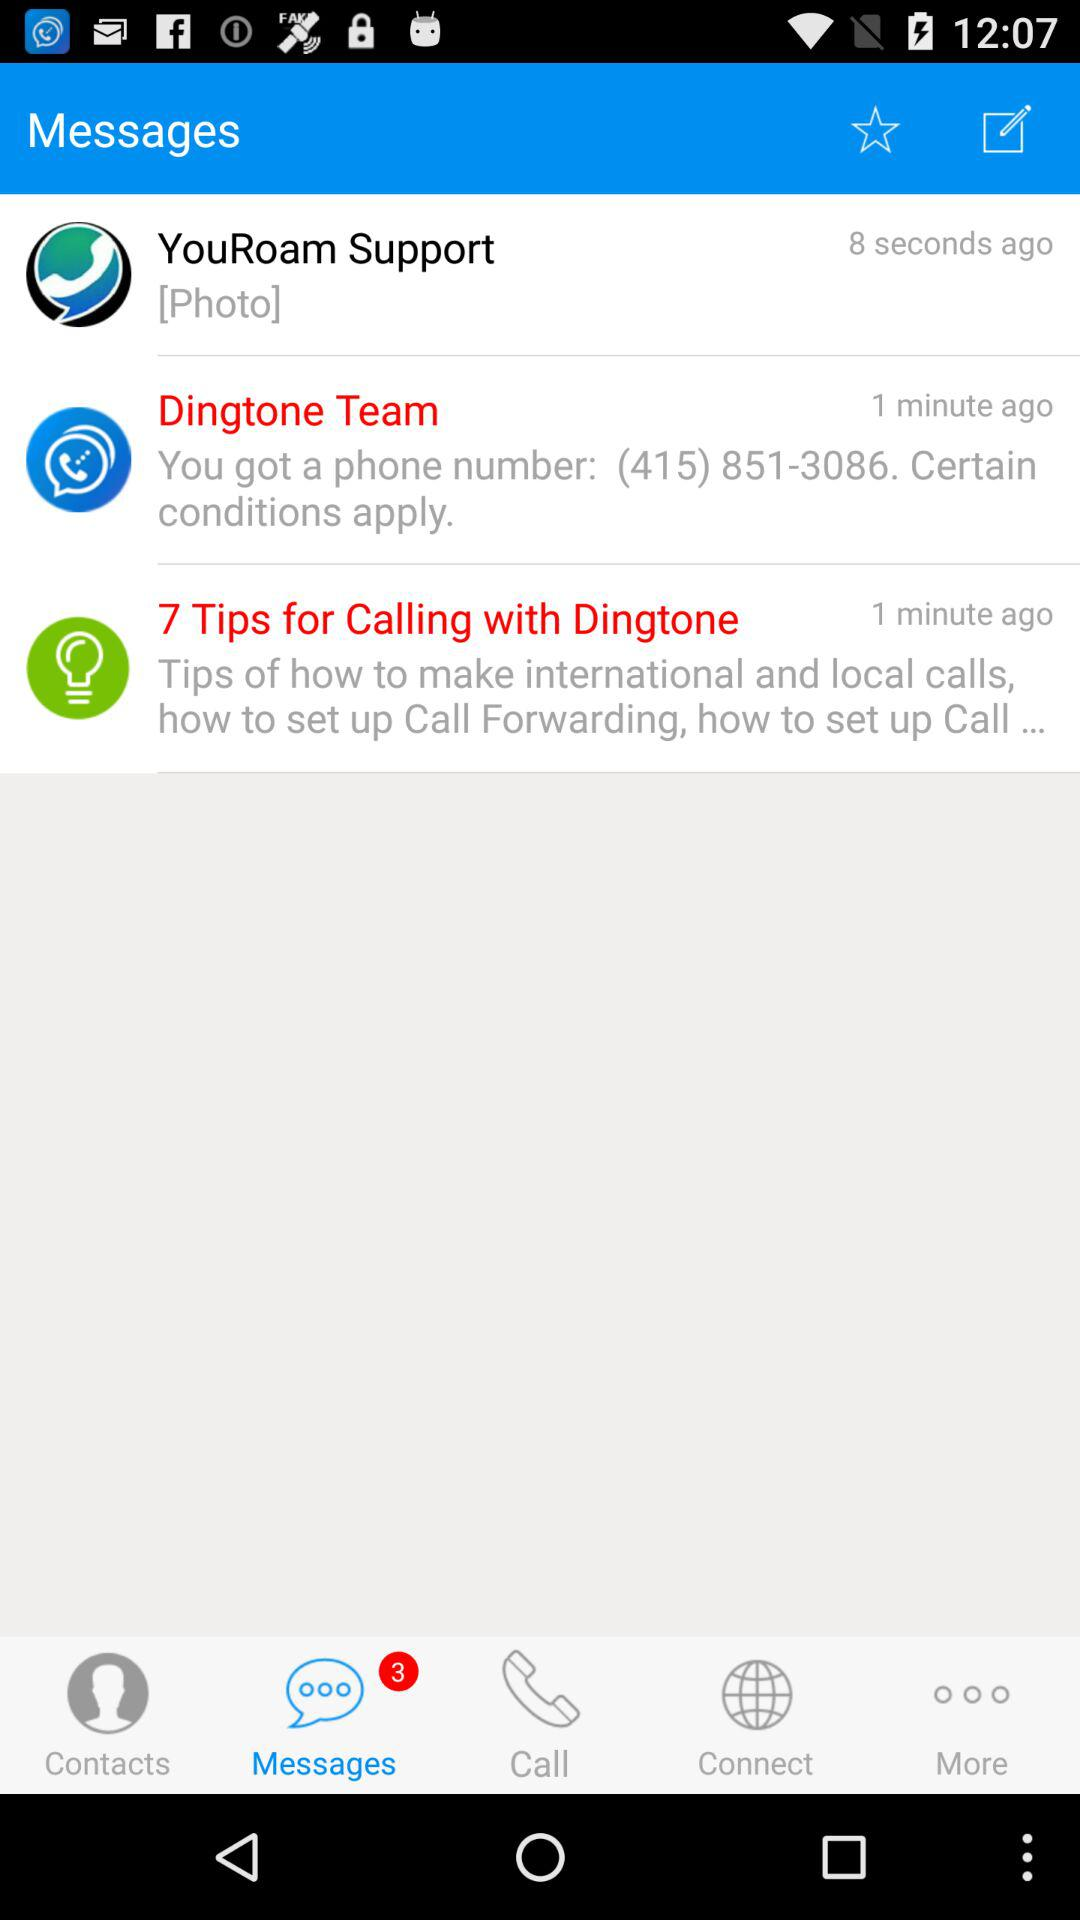How many unread messages are there? There are 3 unread messages. 